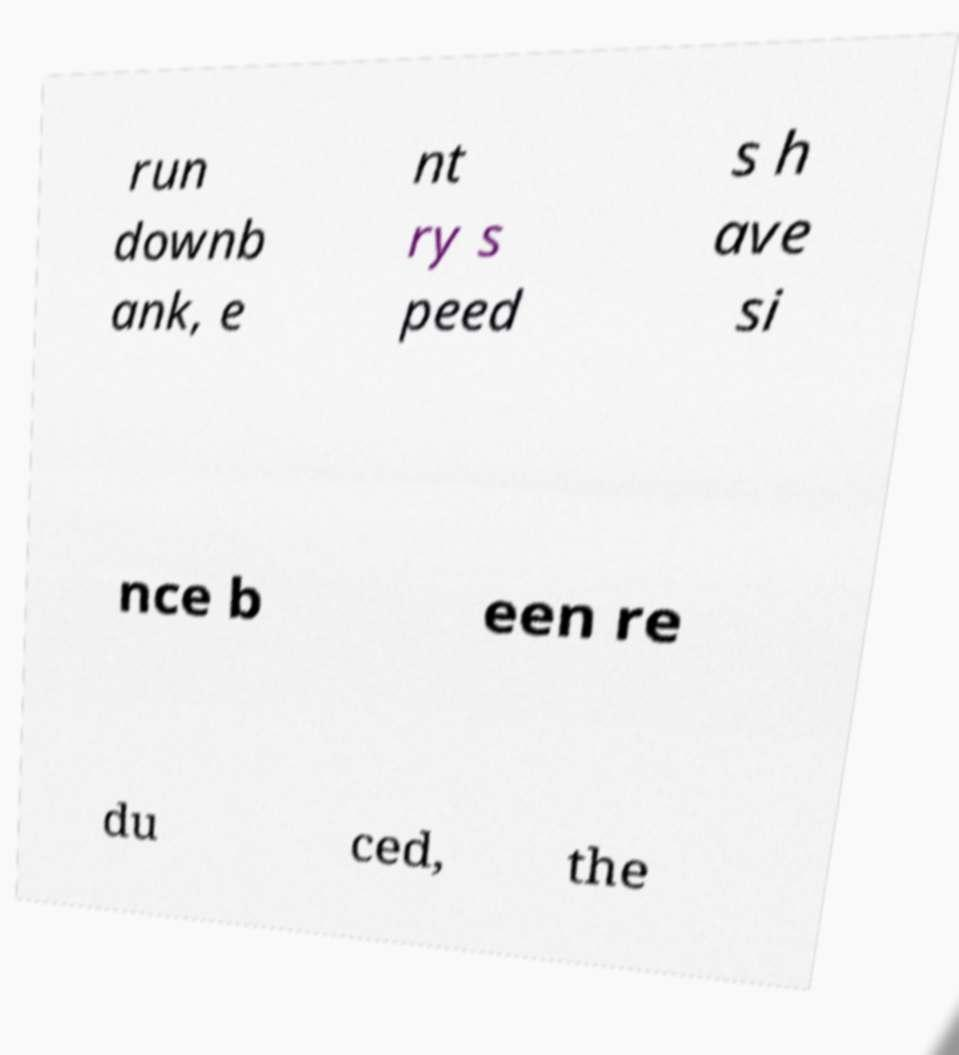Could you extract and type out the text from this image? run downb ank, e nt ry s peed s h ave si nce b een re du ced, the 